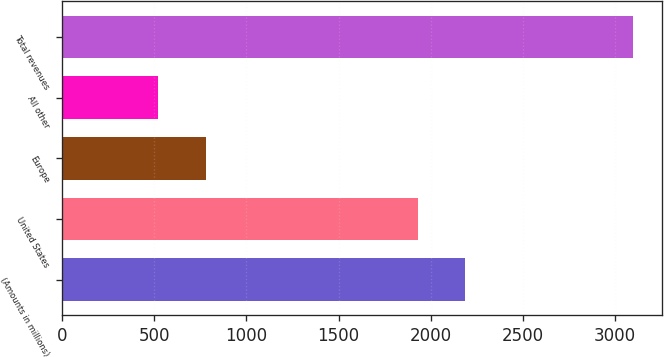Convert chart. <chart><loc_0><loc_0><loc_500><loc_500><bar_chart><fcel>(Amounts in millions)<fcel>United States<fcel>Europe<fcel>All other<fcel>Total revenues<nl><fcel>2188.34<fcel>1930.4<fcel>777.74<fcel>519.8<fcel>3099.2<nl></chart> 